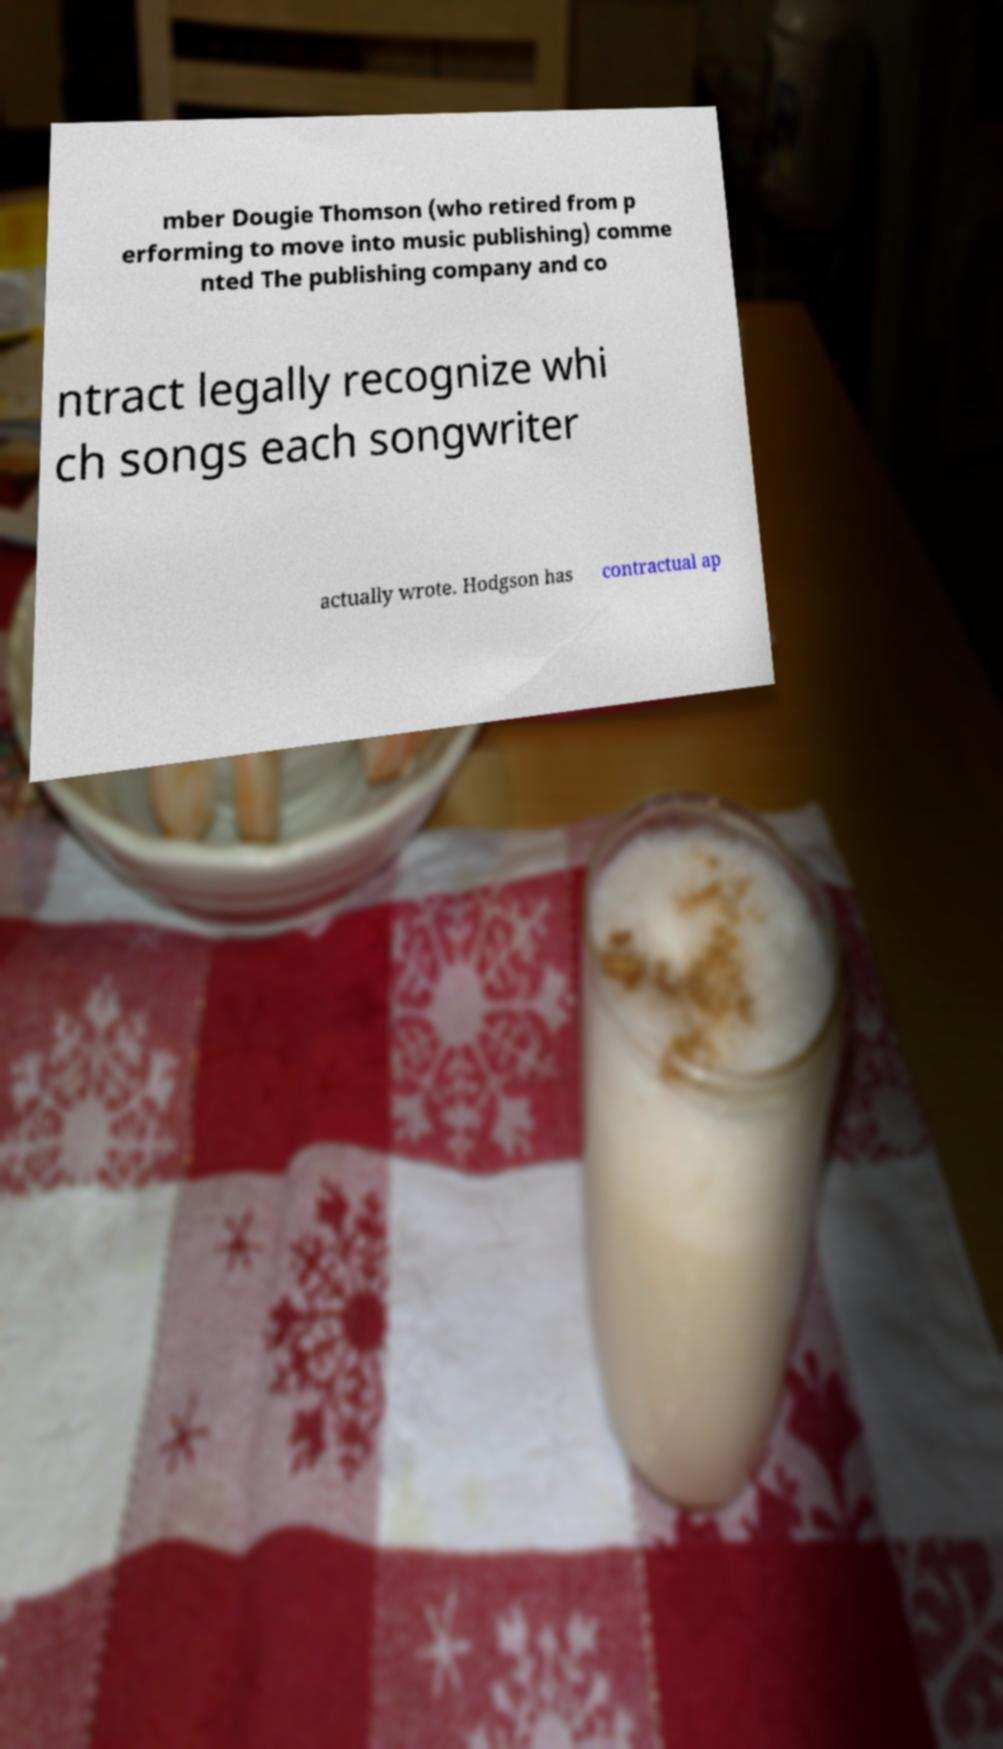Can you accurately transcribe the text from the provided image for me? mber Dougie Thomson (who retired from p erforming to move into music publishing) comme nted The publishing company and co ntract legally recognize whi ch songs each songwriter actually wrote. Hodgson has contractual ap 